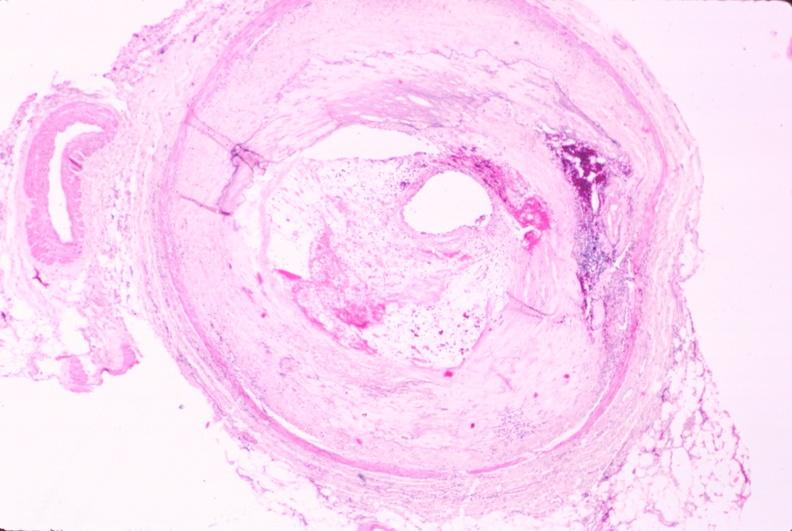what is present?
Answer the question using a single word or phrase. Vasculature 